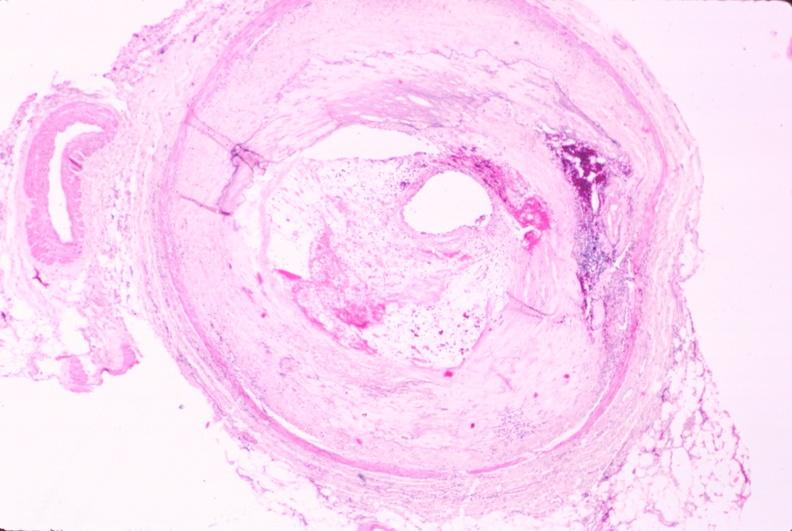what is present?
Answer the question using a single word or phrase. Vasculature 